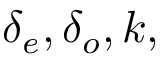Convert formula to latex. <formula><loc_0><loc_0><loc_500><loc_500>\delta _ { e } , \delta _ { o } , k ,</formula> 